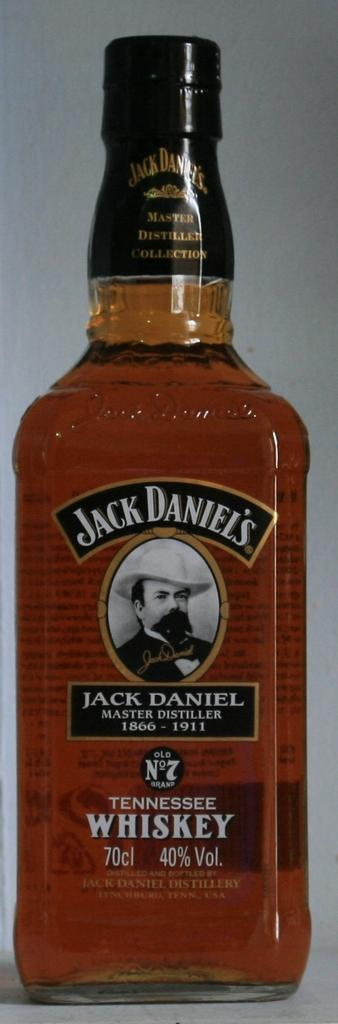Provide a one-sentence caption for the provided image. A bottle full of a gold drink is labeled Jack Daniels. 